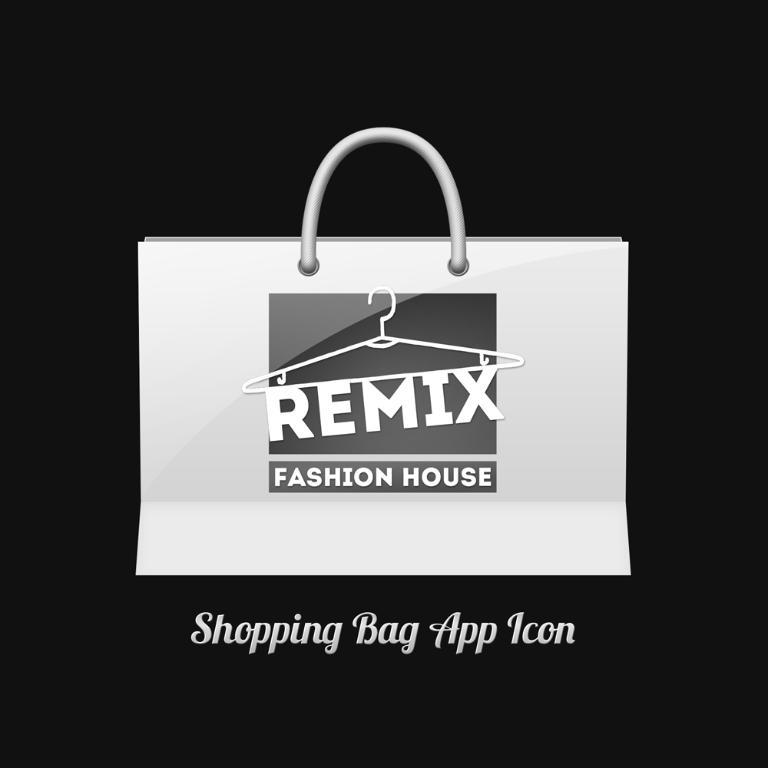What type of picture is the image? The image is an animated picture. What object can be seen in the image? There is a bag in the image. Are there any text elements in the image? Yes, there are words in the image. What is the color of the background in the image? The background of the image is dark. Is there a shirt with a crown on it in the image? There is no shirt or crown present in the image. Does the existence of the bag in the image prove the existence of a parallel universe? The presence of a bag in the image does not prove the existence of a parallel universe; it is simply an object in the image. 